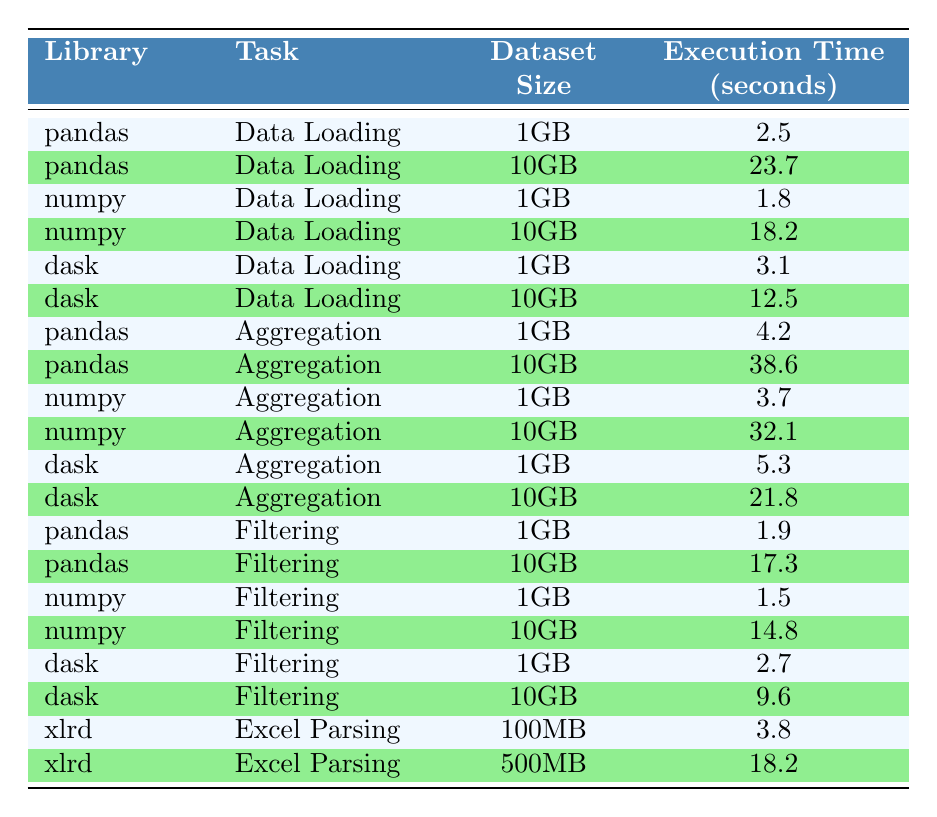What is the execution time for pandas when loading a 1GB dataset? The table shows that for the task "Data Loading" with a "Dataset Size" of "1GB", the execution time for the library "pandas" is 2.5 seconds.
Answer: 2.5 seconds Which library has the shortest execution time for filtering a 10GB dataset? The table indicates that the "Filtering" task with a dataset size of "10GB" takes 17.3 seconds for pandas, 14.8 seconds for numpy, and 9.6 seconds for dask. Since 9.6 seconds is the shortest, dask has the shortest execution time.
Answer: dask What is the difference in execution time for pandas between loading a 1GB dataset and a 10GB dataset? The execution time for loading a "1GB" dataset with pandas is 2.5 seconds, while for a "10GB" dataset, it is 23.7 seconds. The difference is calculated as 23.7 - 2.5 = 21.2 seconds.
Answer: 21.2 seconds Is it true that xlrd takes more time to parse a 500MB dataset compared to pandas loading a 10GB dataset? The table shows xlrd takes 18.2 seconds for "Excel Parsing" with a "500MB" dataset and pandas takes 23.7 seconds for "Data Loading" with a "10GB" dataset. Since 18.2 seconds is less than 23.7 seconds, the statement is false.
Answer: No What is the average execution time for aggregation tasks across all libraries with a 1GB dataset? The execution times for aggregation tasks with a "1GB" dataset are: pandas (4.2 seconds), numpy (3.7 seconds), and dask (5.3 seconds). Adding them gives 4.2 + 3.7 + 5.3 = 13.2 seconds. Dividing by 3 for the average gives 13.2 / 3 = 4.4 seconds.
Answer: 4.4 seconds Which library performs best for data loading with a 10GB dataset in terms of execution time? Analyzing the execution times for data loading with a "10GB" dataset, pandas takes 23.7 seconds, numpy takes 18.2 seconds, and dask takes 12.5 seconds. The smallest execution time is for dask at 12.5 seconds, indicating it performs best for this task.
Answer: dask What is the total execution time for numpy when loading and aggregating a 1GB dataset? The execution time for numpy when loading a "1GB" dataset is 1.8 seconds and for aggregation, it is 3.7 seconds. The total execution time is 1.8 + 3.7 = 5.5 seconds.
Answer: 5.5 seconds Does dask show a consistent trend of increasing execution times as the dataset size increases? For dask, the execution times for the data loading task show an increase from 3.1 seconds for "1GB" to 12.5 seconds for "10GB", and for the aggregation task, it increases from 5.3 seconds to 21.8 seconds, confirming that dask shows a consistent trend of increasing execution times with larger datasets.
Answer: Yes 